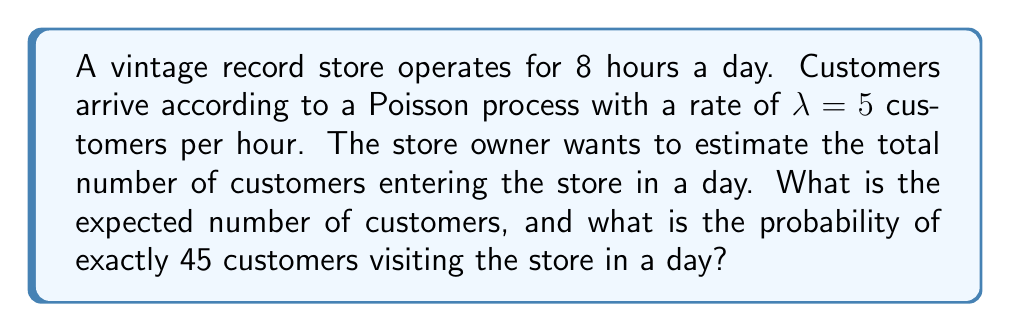Teach me how to tackle this problem. Let's approach this problem step-by-step:

1. Expected number of customers:
   - The arrival process is Poisson with rate $\lambda = 5$ customers per hour.
   - The store operates for 8 hours.
   - The expected number of customers in 8 hours is:
     $$E[N(8)] = \lambda t = 5 \cdot 8 = 40$$ customers

2. Probability of exactly 45 customers in a day:
   - We use the Poisson probability mass function:
     $$P(N(t) = k) = \frac{e^{-\lambda t}(\lambda t)^k}{k!}$$
   - Here, $\lambda t = 5 \cdot 8 = 40$ and $k = 45$
   - Substituting these values:
     $$P(N(8) = 45) = \frac{e^{-40}(40)^{45}}{45!}$$
   - Using a calculator or computer:
     $$P(N(8) = 45) \approx 0.0488$$ or about 4.88%

Therefore, the expected number of customers in a day is 40, and the probability of exactly 45 customers visiting the store in a day is approximately 0.0488 or 4.88%.
Answer: Expected customers: 40; Probability of 45 customers: 0.0488 